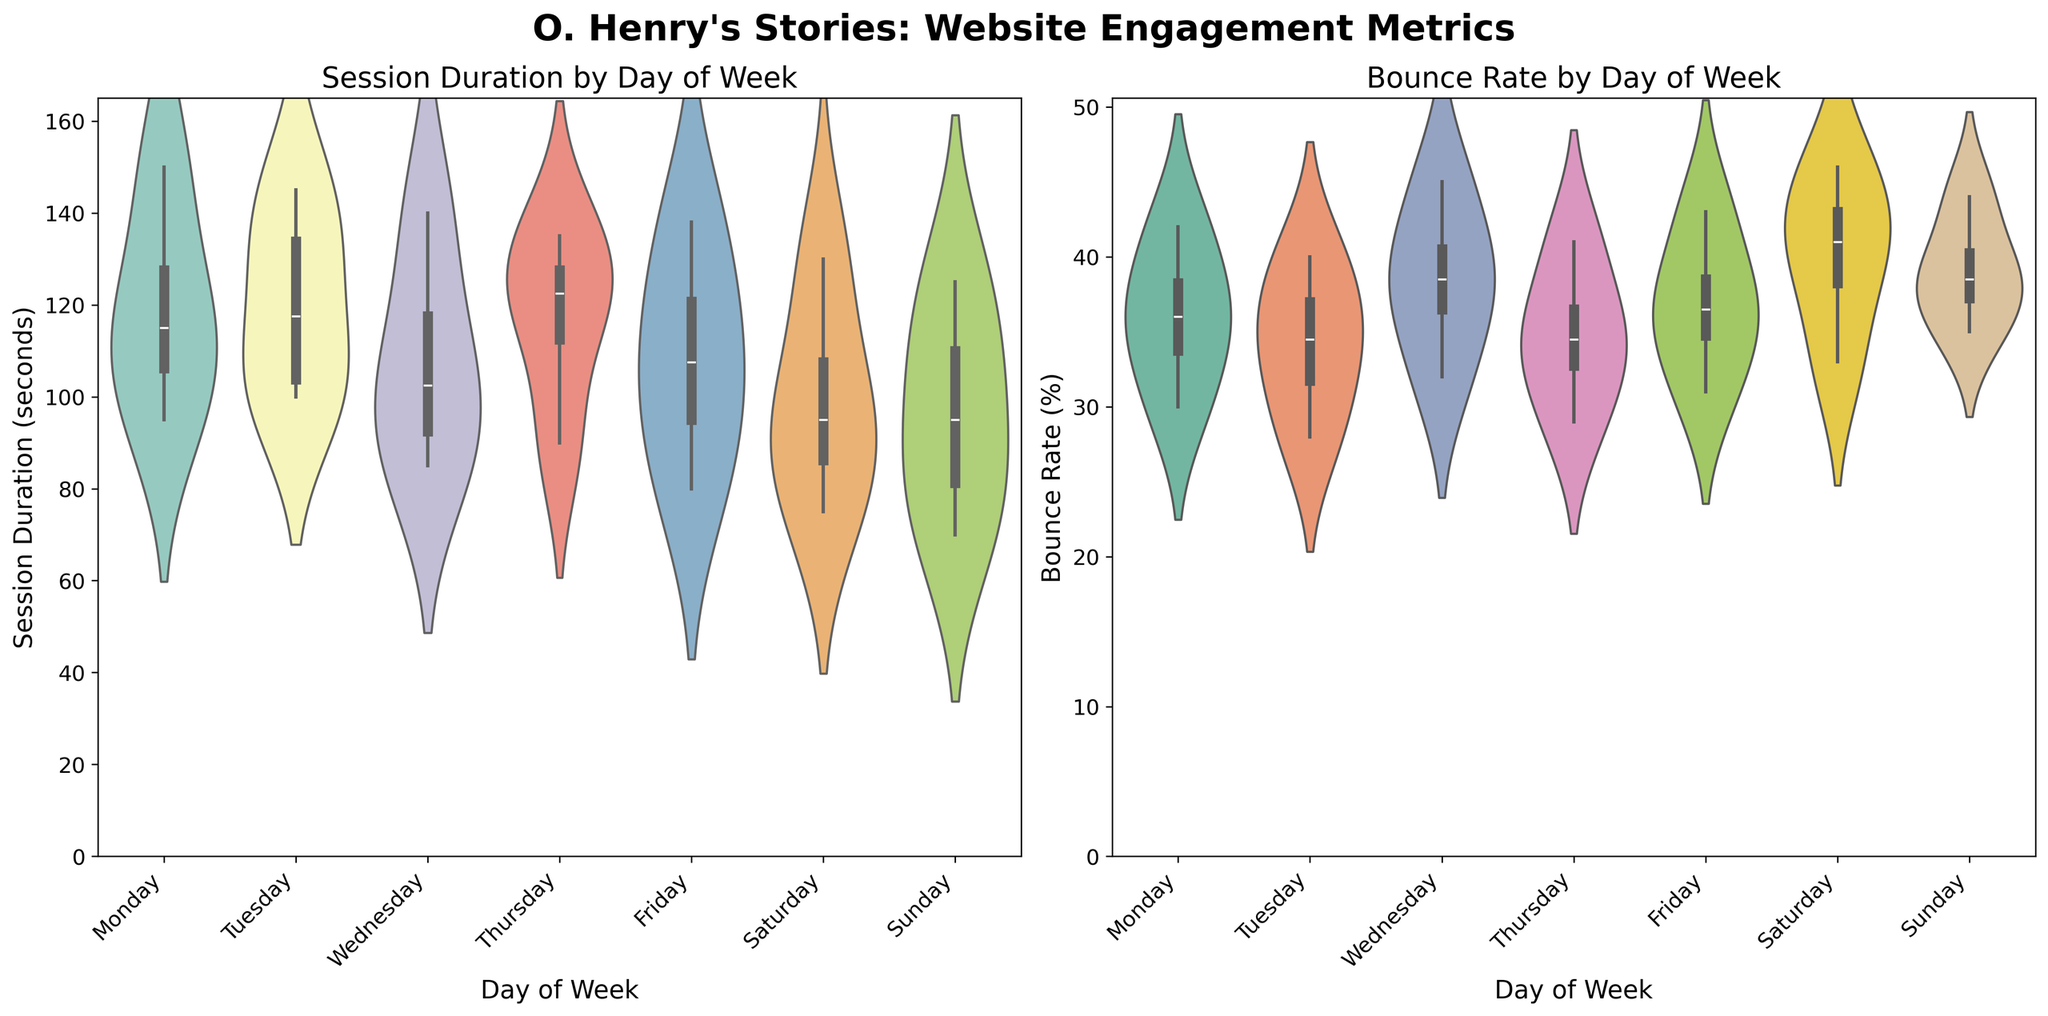What is the average session duration on Monday? To find the average session duration on Monday, sum the session duration values for Monday and divide by the number of data points. The values are 120, 150, 95, and 110. Therefore, (120 + 150 + 95 + 110) / 4 = 118.75.
Answer: 118.75 seconds On which day is the median bounce rate the highest? To determine the median bounce rate for each day, observe the violin plots for the bounce rate for each day. We see that Saturday's bounce rate has the highest median.
Answer: Saturday Which day shows the most variability in session duration? To find the day with the most variability, look at the width of the violin plots at various points along the y-axis. Wednesday has the widest spread of session durations, reflecting the most variability.
Answer: Wednesday Which day has the highest median session duration? By looking at the bulges in the violin plots for session duration, Tuesday shows the highest median, indicated by the wider central part of the plot.
Answer: Tuesday Compare the median bounce rate on Saturday and Tuesday. Which is higher? By observing the central width of the violin plots for bounce rate on Saturday and Tuesday, we see that the median bounce rate on Saturday is higher.
Answer: Saturday What is the range of session duration on Friday? To find the range, identify the minimum and maximum session durations on Friday from the violin plot. The range can be observed from approximately 80 to 138 seconds.
Answer: 58 seconds Which day has the lowest median bounce rate? By inspecting the central sections of the bounce rate violin plots, Tuesday has the lowest median bounce rate.
Answer: Tuesday Which day appears to have the most consistent bounce rate? A consistent bounce rate is indicated by the narrowest violin plot. Monday's bounce rate plot is the narrowest, indicating consistency.
Answer: Monday What is the difference between the median session duration on Monday and Saturday? To find the difference, observe the median positions on the violin plots. The median on Monday is around 110, and on Saturday, it's around 100. Therefore, 110 - 100 = 10.
Answer: 10 seconds Does Sunday have a lower or higher average session duration compared to Monday? By comparing the overall thickness and distribution for Sunday and Monday's session duration violin plots, Monday's average session duration is higher.
Answer: Higher 